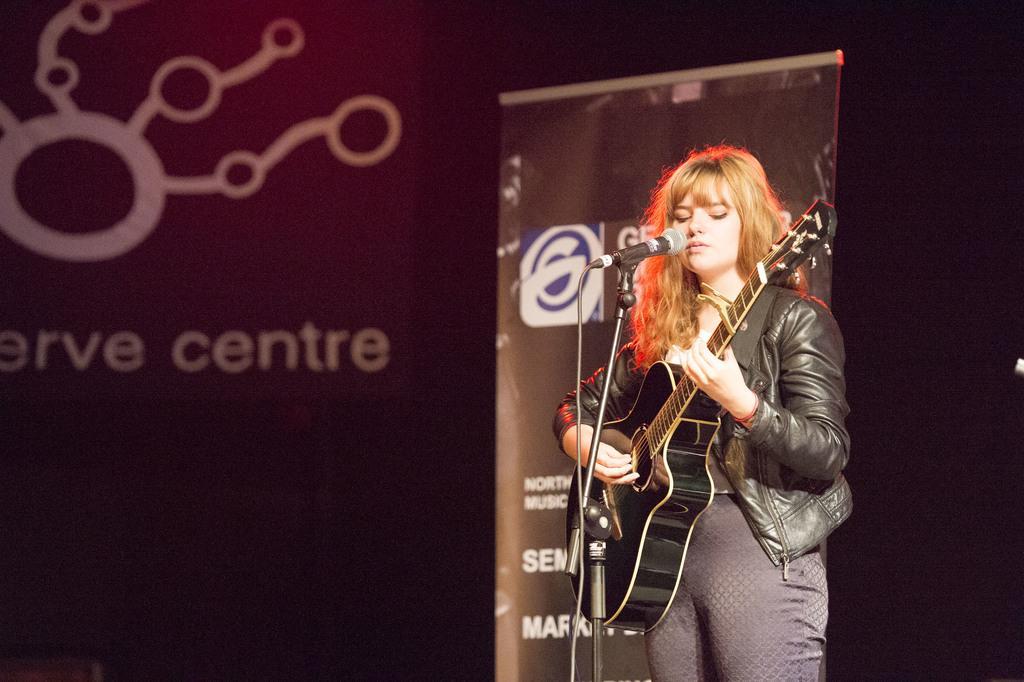In one or two sentences, can you explain what this image depicts? In this image there is a woman standing and playing a guitar and singing a song in the microphone , and the back ground there is a banner and hoarding. 